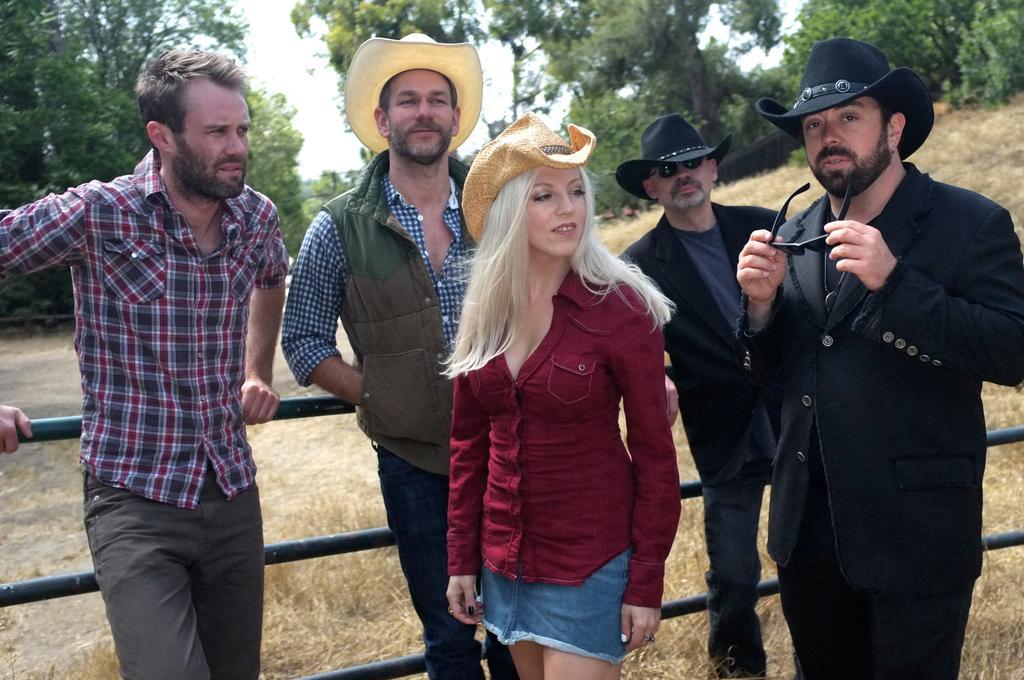Please provide a concise description of this image. In this image we can see people standing. There is a black color railing. In the background of the image there are trees. At the bottom of the image there is grass. 